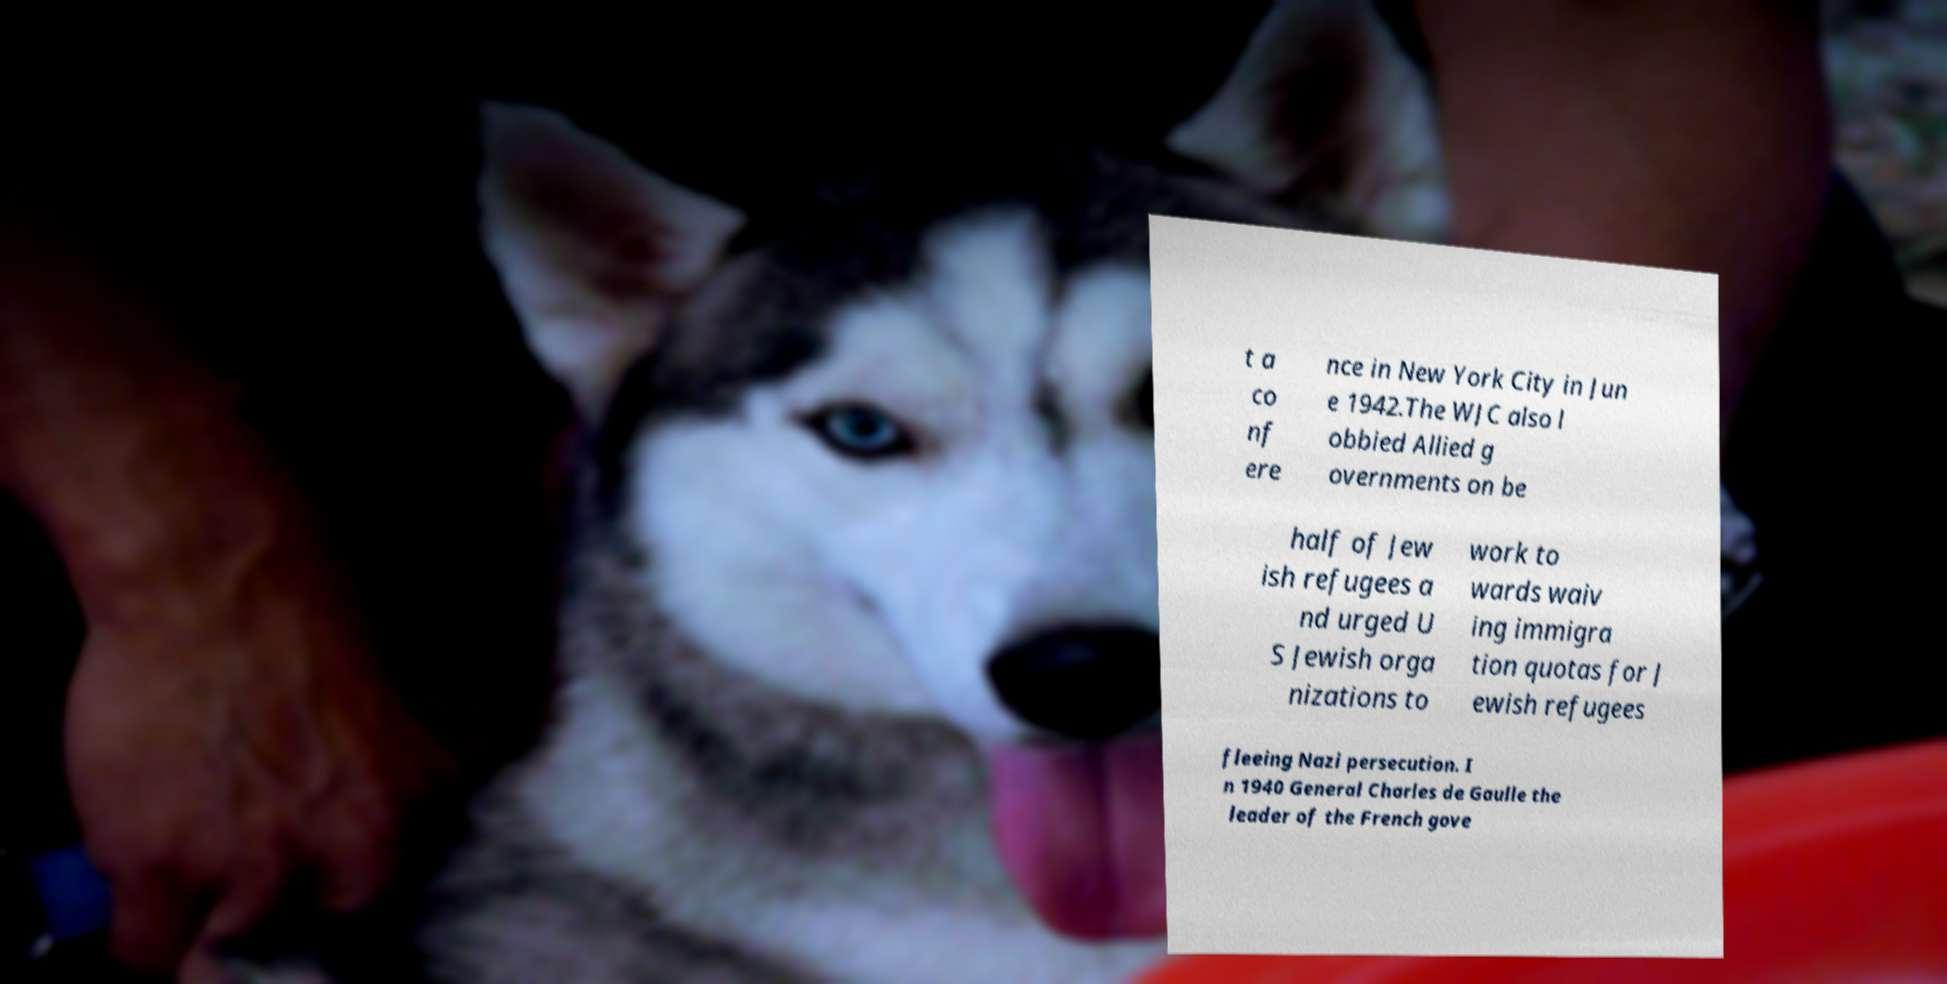Can you read and provide the text displayed in the image?This photo seems to have some interesting text. Can you extract and type it out for me? t a co nf ere nce in New York City in Jun e 1942.The WJC also l obbied Allied g overnments on be half of Jew ish refugees a nd urged U S Jewish orga nizations to work to wards waiv ing immigra tion quotas for J ewish refugees fleeing Nazi persecution. I n 1940 General Charles de Gaulle the leader of the French gove 